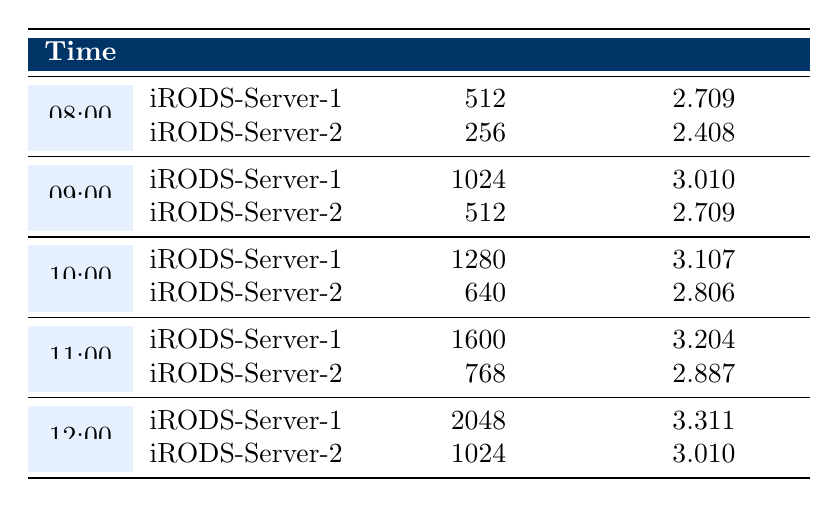What's the memory usage of iRODS-Server-1 at 12:00? From the table, under the column "Memory (MB)" for iRODS-Server-1 at the time "12:00", the value is 2048.
Answer: 2048 What is the logarithmic memory usage for iRODS-Server-2 at 10:00? Looking at the entry for iRODS-Server-2 at the timestamp "10:00", the column "Log Memory" shows a value of 2.806.
Answer: 2.806 What is the difference in memory usage between iRODS-Server-1 and iRODS-Server-2 at 11:00? For iRODS-Server-1 at "11:00", the memory usage is 1600 MB and for Server-2, it is 768 MB. The difference is calculated as 1600 - 768 = 832 MB.
Answer: 832 Was the memory usage for iRODS-Server-2 higher than 512 MB at any hour? Checking the memory usage data, for iRODS-Server-2 at "12:00", the memory usage is 1024 MB, which is greater than 512 MB. Therefore, the statement is true.
Answer: Yes What is the average memory usage for iRODS-Server-1 from 08:00 to 12:00? The memory values for iRODS-Server-1 from 08:00 to 12:00 are 512, 1024, 1280, 1600, and 2048 MB. The total memory used is 512 + 1024 + 1280 + 1600 + 2048 = 5464 MB. There are 5 data points, thus the average is 5464 / 5 = 1092.8 MB.
Answer: 1092.8 How much did the logarithmic memory usage increase from 08:00 to 12:00 for iRODS-Server-1? To find the increase, we subtract the logarithmic memory usage at 08:00 (2.709) from that at 12:00 (3.311): 3.311 - 2.709 = 0.602.
Answer: 0.602 At what hour did iRODS-Server-1 have the highest memory usage? Reviewing the memory usage values for iRODS-Server-1, the highest usage is at "12:00" with 2048 MB, which is greater than all previous hours.
Answer: 12:00 Is the logarithmic memory usage of iRODS-Server-2 at 09:00 higher than that at 08:00? Checking the values, at "09:00" for iRODS-Server-2 the logarithmic memory usage is 2.709, and at "08:00" it is 2.408. Since 2.709 > 2.408, the statement is true.
Answer: Yes 